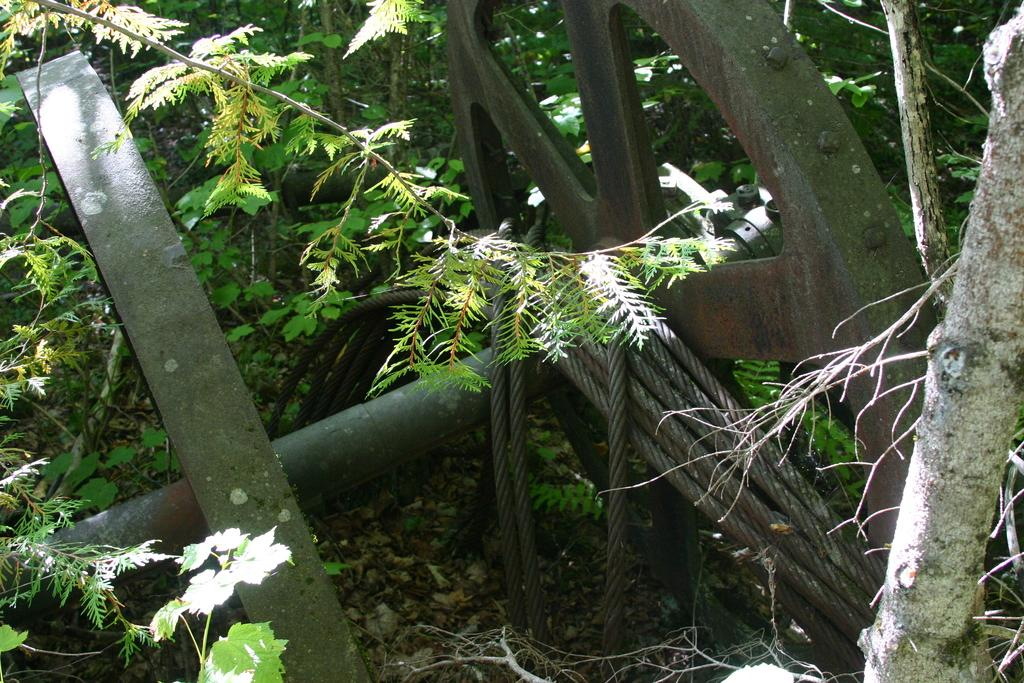What type of objects are made of iron in the image? There are iron objects in the image. What is used to tie or hold things together in the image? There is rope in the image. What type of vegetation is present in the image? There are plants in the image. What part of the plants can be seen in the image? There are leaves in the image. What type of pipe is visible in the image? There is no pipe present in the image. Can you describe the cat sitting on the leaves in the image? There is no cat present in the image; it only features iron objects, rope, plants, and leaves. 